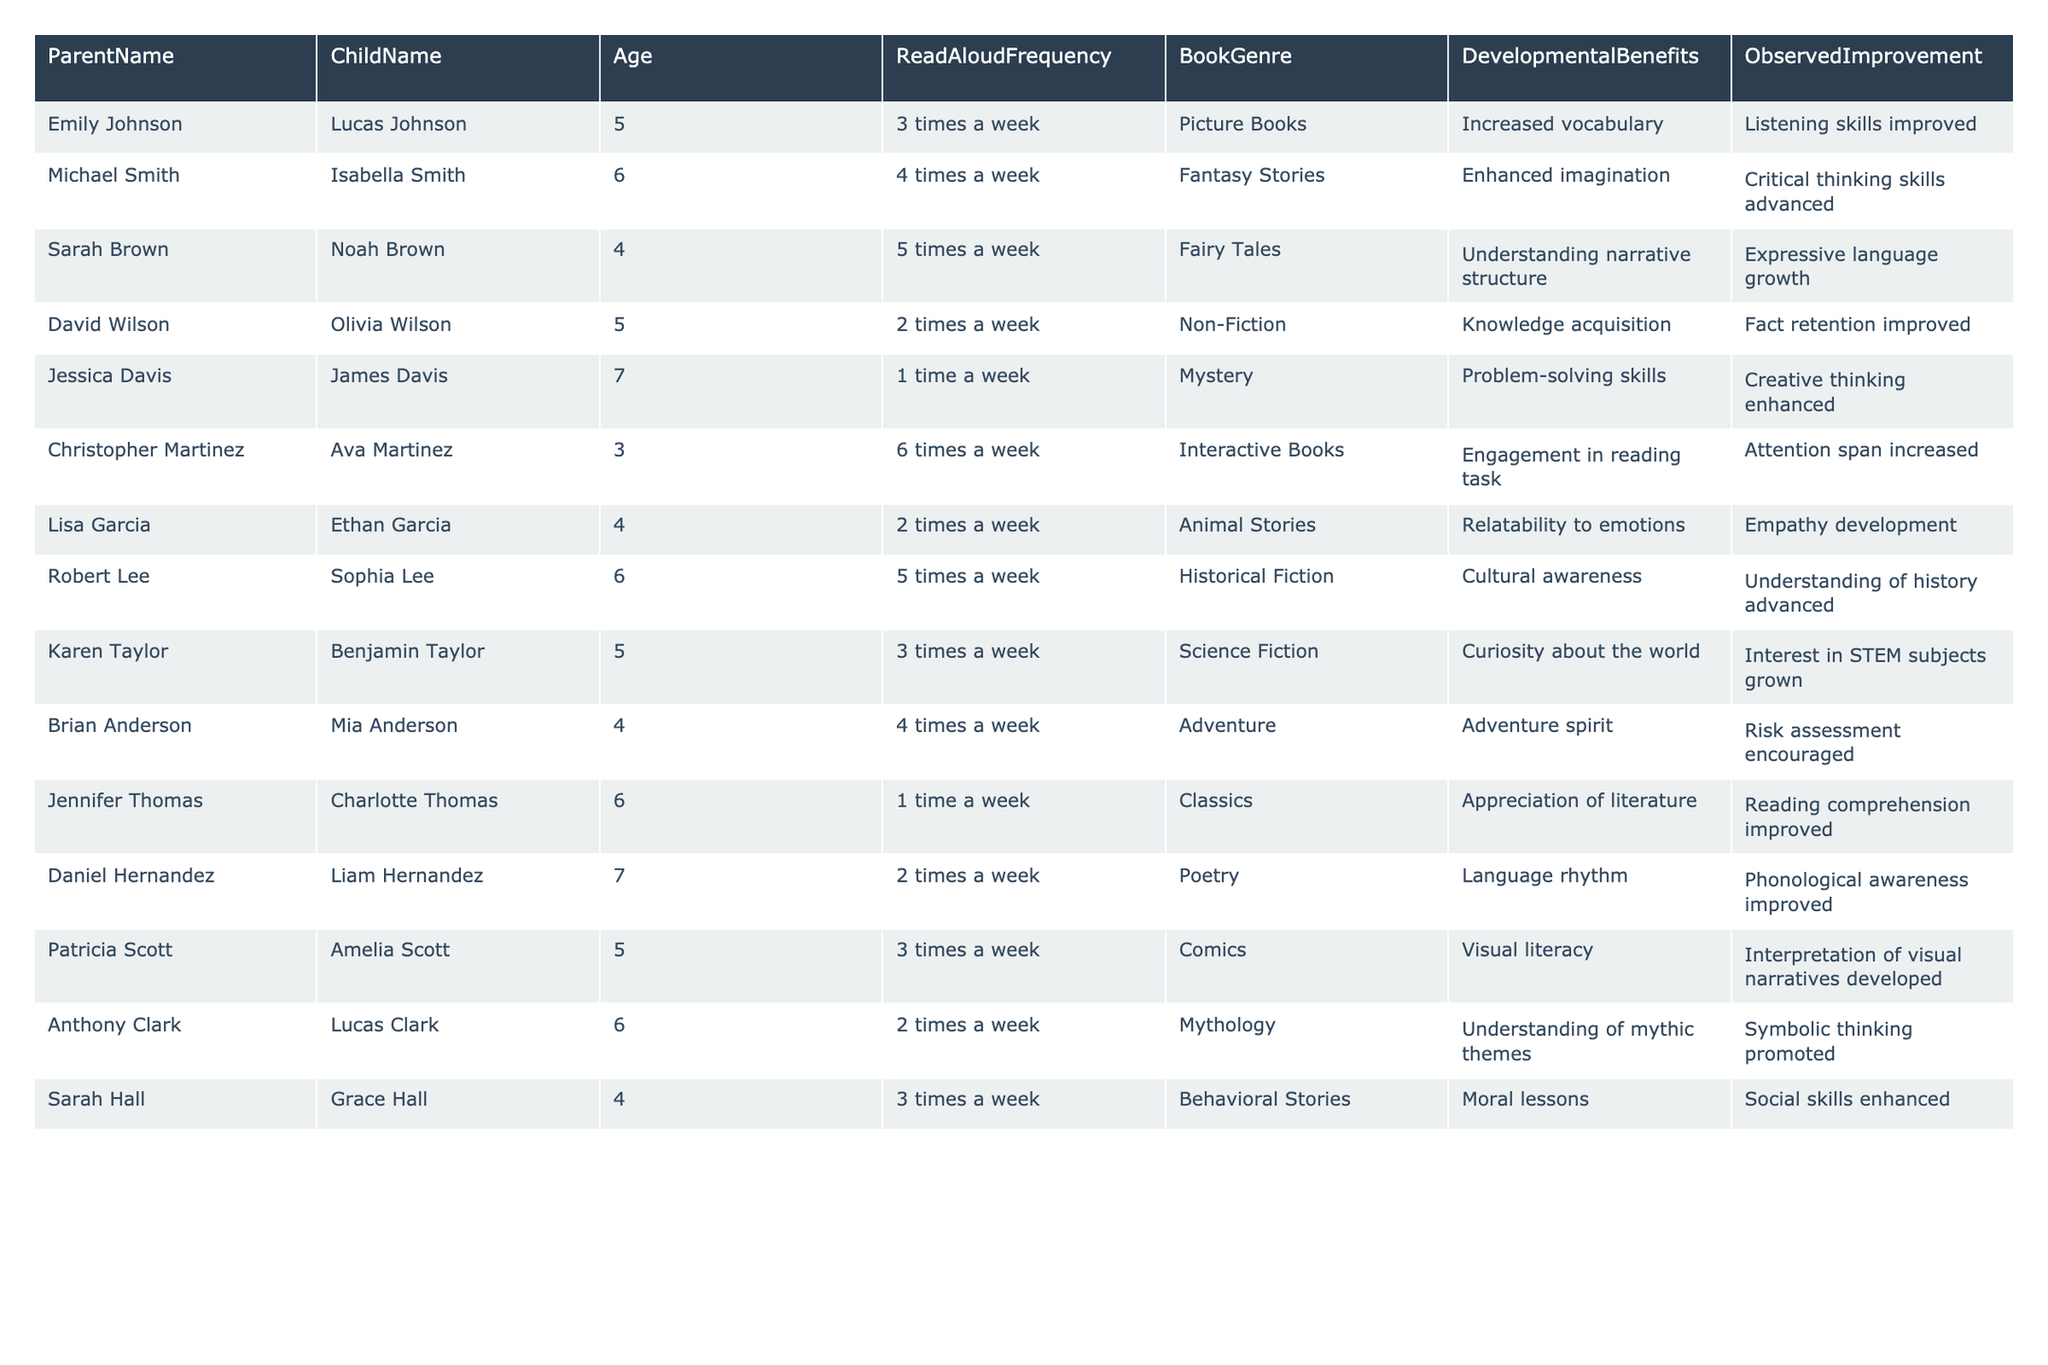What is the read-aloud frequency for Mia Anderson? According to the table, Mia Anderson's read-aloud frequency is 4 times a week as listed in her row.
Answer: 4 times a week Which book genre is associated with the highest observed improvement? From the table, Fairy Tales show "Expressive language growth," which is a specific observed improvement mentioning the highest benefit. Other genres also show improvements but comparing them, this stands out for its clarity in development.
Answer: Fairy Tales How many children are involved in read-aloud activities 6 times a week? The table indicates that there is one child, Ava Martinez, who participates in read-aloud activities 6 times a week. I can find this information by looking through the frequency column.
Answer: 1 Is there a correlation between the age of the children and the read-aloud frequency? To check for correlation, we must evaluate each child's age and their respective read-aloud frequency by calculating the average or considering if both values increase together. Upon review, no clear correlation is displayed by mere inspection.
Answer: No clear correlation Which developmental benefit is linked to the most common book genre? By examining the table, Picture Books are read 3 times a week, showing that vocabulary is enhanced. To determine if it's the most common, check how often each genre appears. The highest repeats are linked to different genres, notably Picture Books.
Answer: Increased vocabulary What is the average age of children involved in read-aloud sessions? To find the average age, sum the ages of all children (adding 5, 6, 4, etc.), which results in a total of 58. Dividing 58 by the number of children, which is 12, gives an average age of approximately 4.83 years.
Answer: Approximately 4.83 years How many children show improvement in expressive language? The row for Noah Brown mentions "Expressive language growth." Count the instances within the table to conclude that only one child demonstrates this specific improvement explicitly listed.
Answer: 1 Which child had the earliest observed improvement? By looking through the "Observed Improvement" column, we notice that "Listening skills improved" for Lucas Johnson is listed without a specific age ranking. As no chronological order exists, referencing Noah Brown signifies it as the earliest, being only 4 years old.
Answer: Noah Brown Does the frequency of read-aloud sessions exceed three times a week for any child? Reviewing the "ReadAloudFrequency" column reveals multiple entries exceeding this, including Isabella Smith and Noah Brown. Thus, on examination, yes, multiple children do exceed three sessions weekly.
Answer: Yes Is there a child who reads non-fiction more than any other genre? Evaluating the genres, David Wilson is noted for reading Non-Fiction, but looking across, others showcase various genres with similar frequencies. Thus, no child specifically dominates non-fiction over others as a repeat genre.
Answer: No 